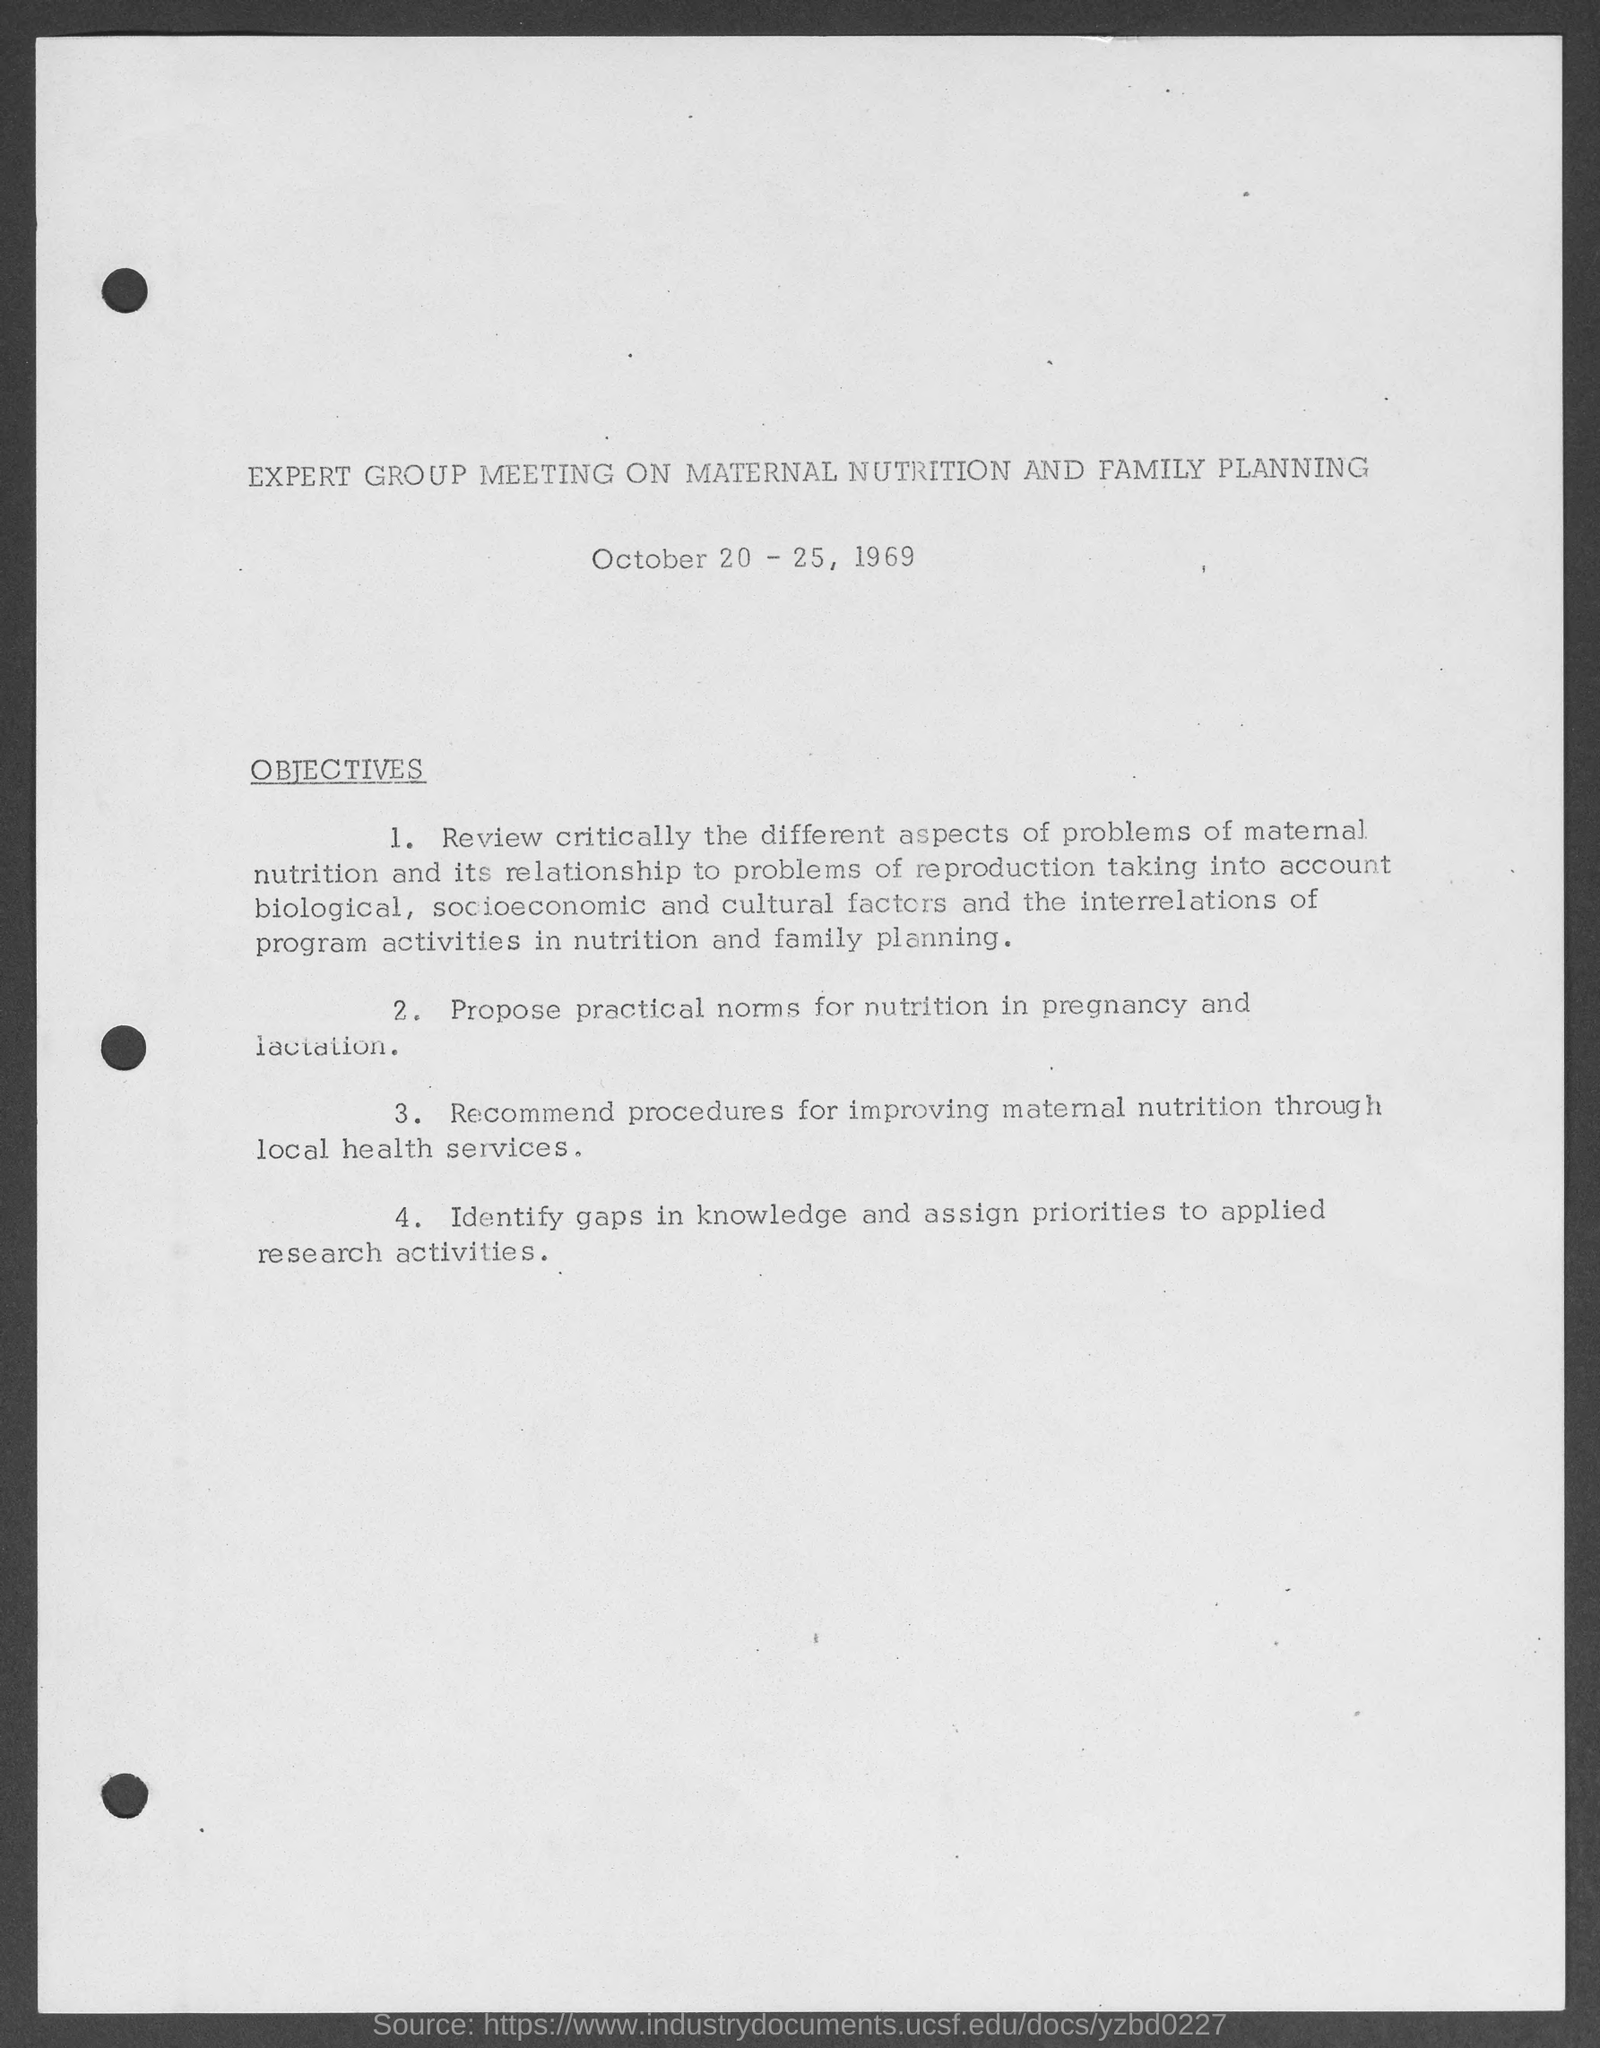Mention a couple of crucial points in this snapshot. The expert group meeting is about maternal nutrition and family planning. The meeting is scheduled to take place from October 20 through October 25, 1969. 